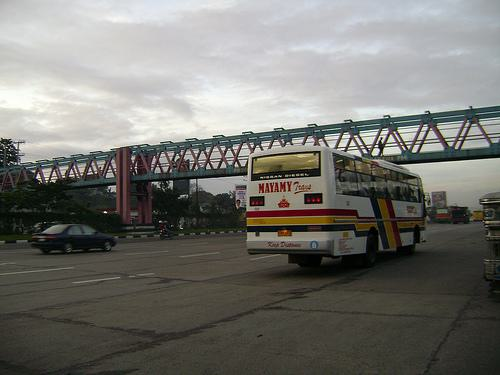What kind of bus is in the image, and does the sign on it provide any information about its route or destination? The bus in the image is a public transit bus, likely used for city or regional transportation. While the specific details on the sign are not entirely legible, it does contain the word 'Mayamy' which may suggest either the brand or a location related to its route or destination. 